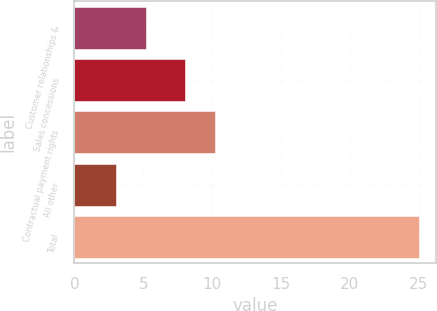<chart> <loc_0><loc_0><loc_500><loc_500><bar_chart><fcel>Customer relationships &<fcel>Sales concessions<fcel>Contractual payment rights<fcel>All other<fcel>Total<nl><fcel>5.2<fcel>8<fcel>10.2<fcel>3<fcel>25<nl></chart> 